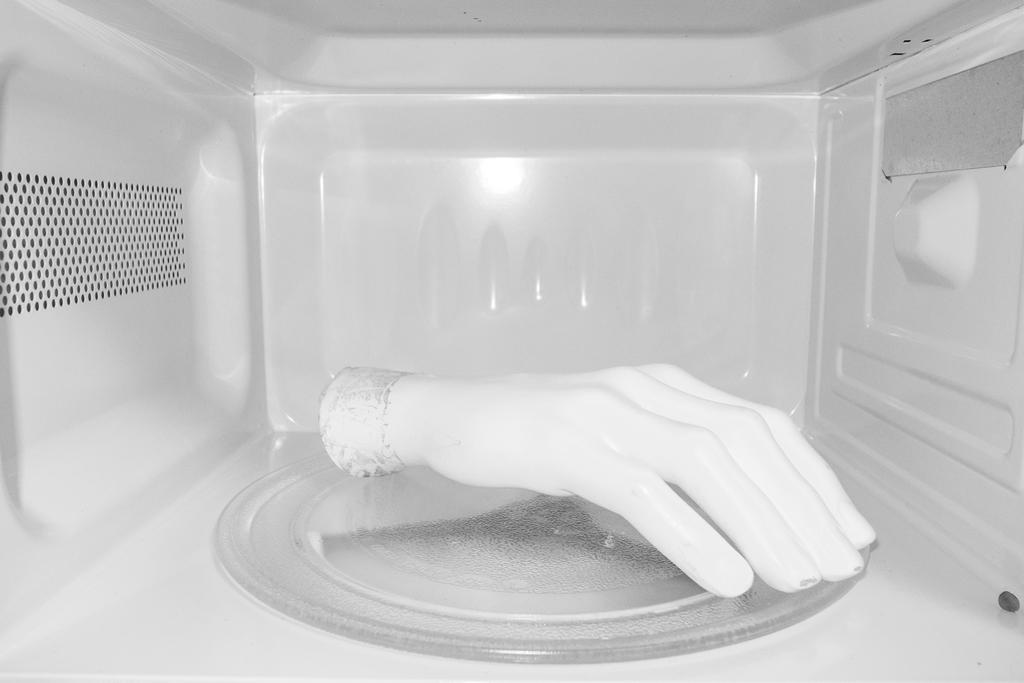How would you summarize this image in a sentence or two? In this image we can see hand in a microwave oven. 